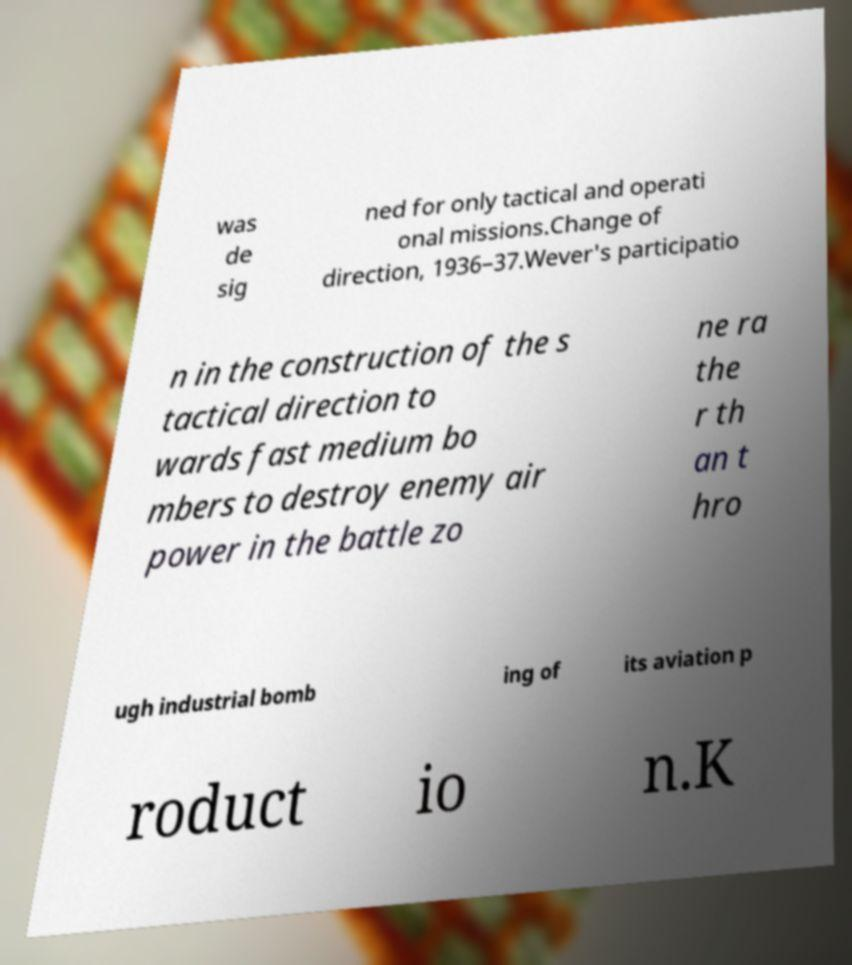Please identify and transcribe the text found in this image. was de sig ned for only tactical and operati onal missions.Change of direction, 1936–37.Wever's participatio n in the construction of the s tactical direction to wards fast medium bo mbers to destroy enemy air power in the battle zo ne ra the r th an t hro ugh industrial bomb ing of its aviation p roduct io n.K 